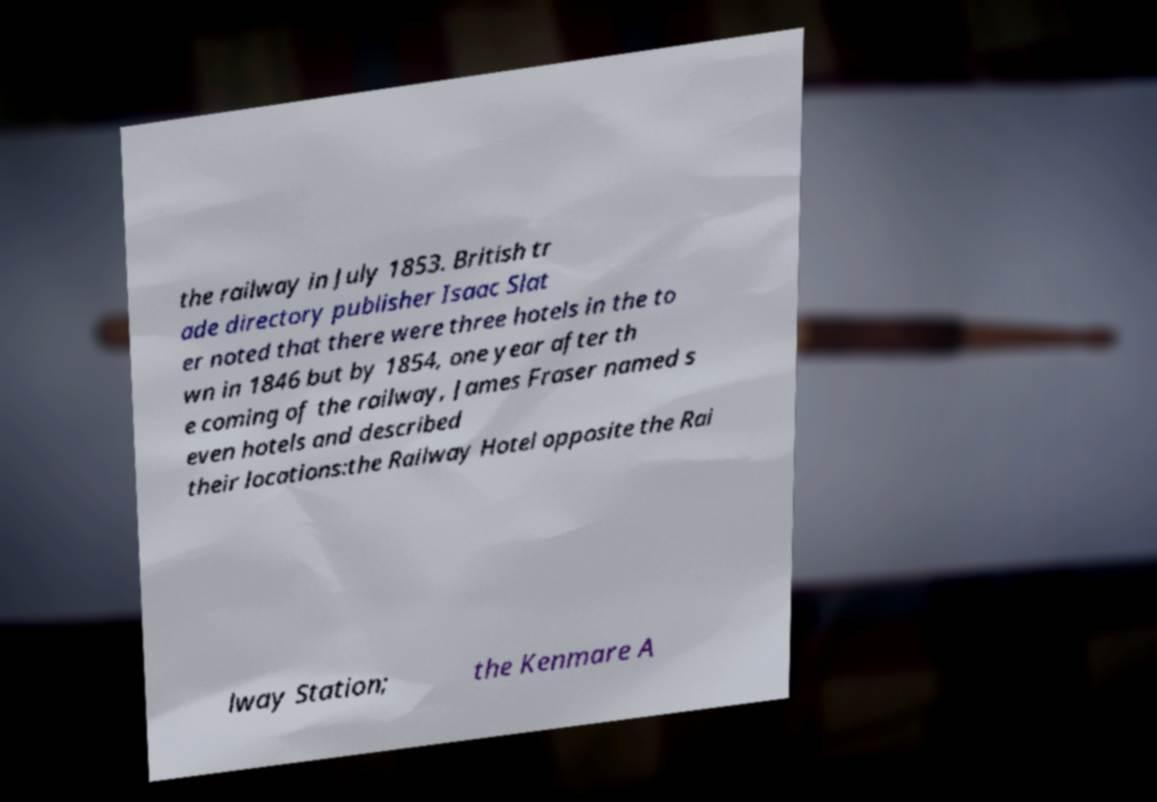I need the written content from this picture converted into text. Can you do that? the railway in July 1853. British tr ade directory publisher Isaac Slat er noted that there were three hotels in the to wn in 1846 but by 1854, one year after th e coming of the railway, James Fraser named s even hotels and described their locations:the Railway Hotel opposite the Rai lway Station; the Kenmare A 